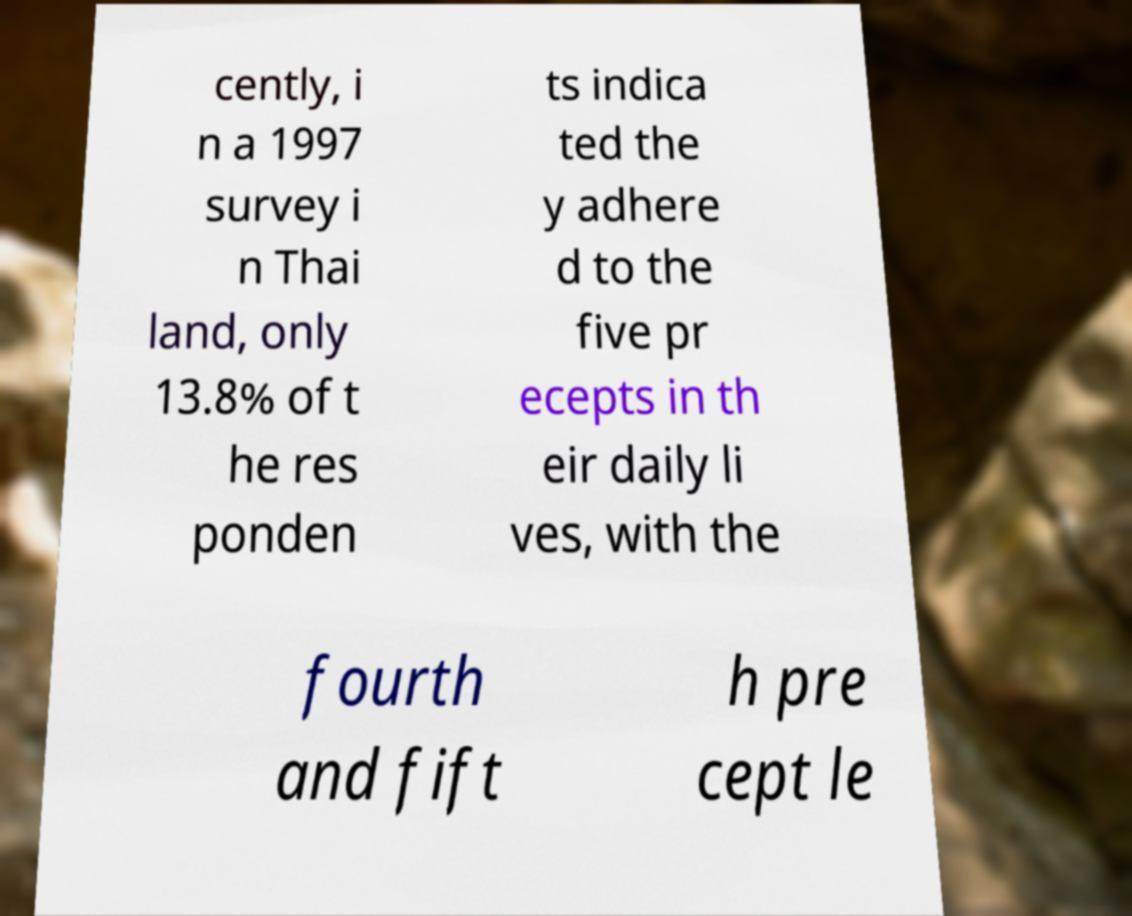Can you read and provide the text displayed in the image?This photo seems to have some interesting text. Can you extract and type it out for me? cently, i n a 1997 survey i n Thai land, only 13.8% of t he res ponden ts indica ted the y adhere d to the five pr ecepts in th eir daily li ves, with the fourth and fift h pre cept le 